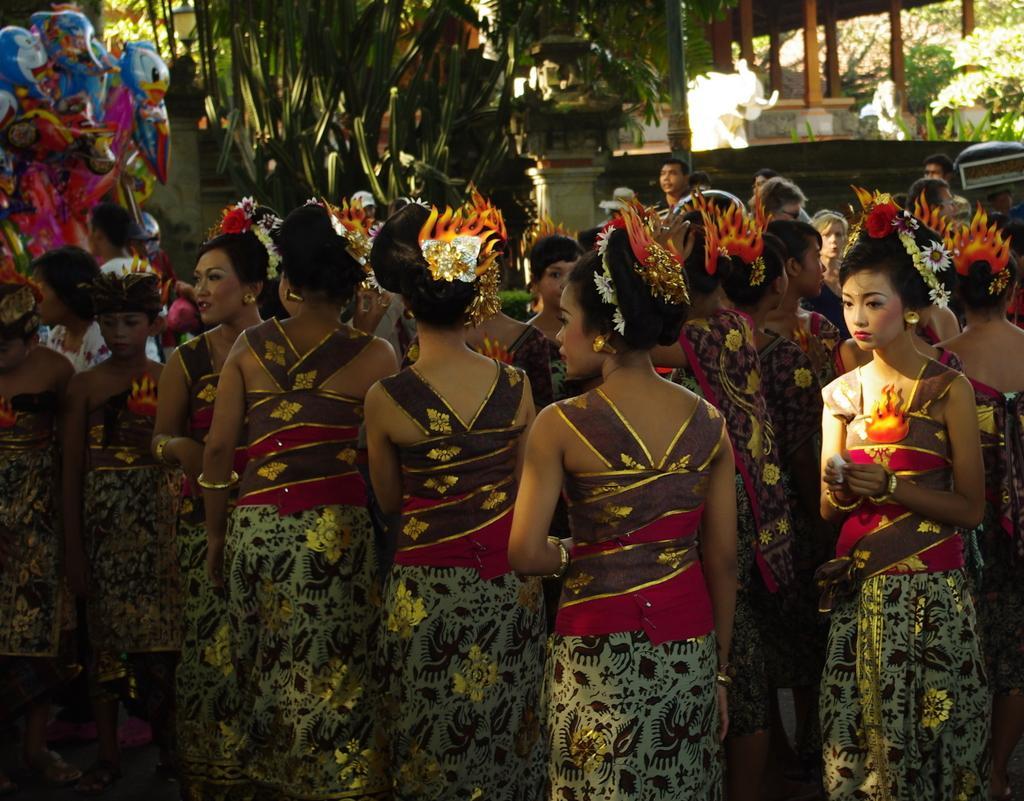In one or two sentences, can you explain what this image depicts? In this image I can see a group of people standing. In the background, I can see the trees and the wooden pillars. 